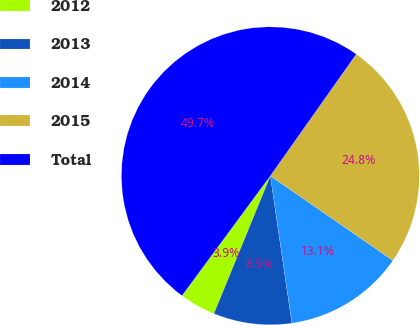<chart> <loc_0><loc_0><loc_500><loc_500><pie_chart><fcel>2012<fcel>2013<fcel>2014<fcel>2015<fcel>Total<nl><fcel>3.92%<fcel>8.5%<fcel>13.07%<fcel>24.84%<fcel>49.67%<nl></chart> 